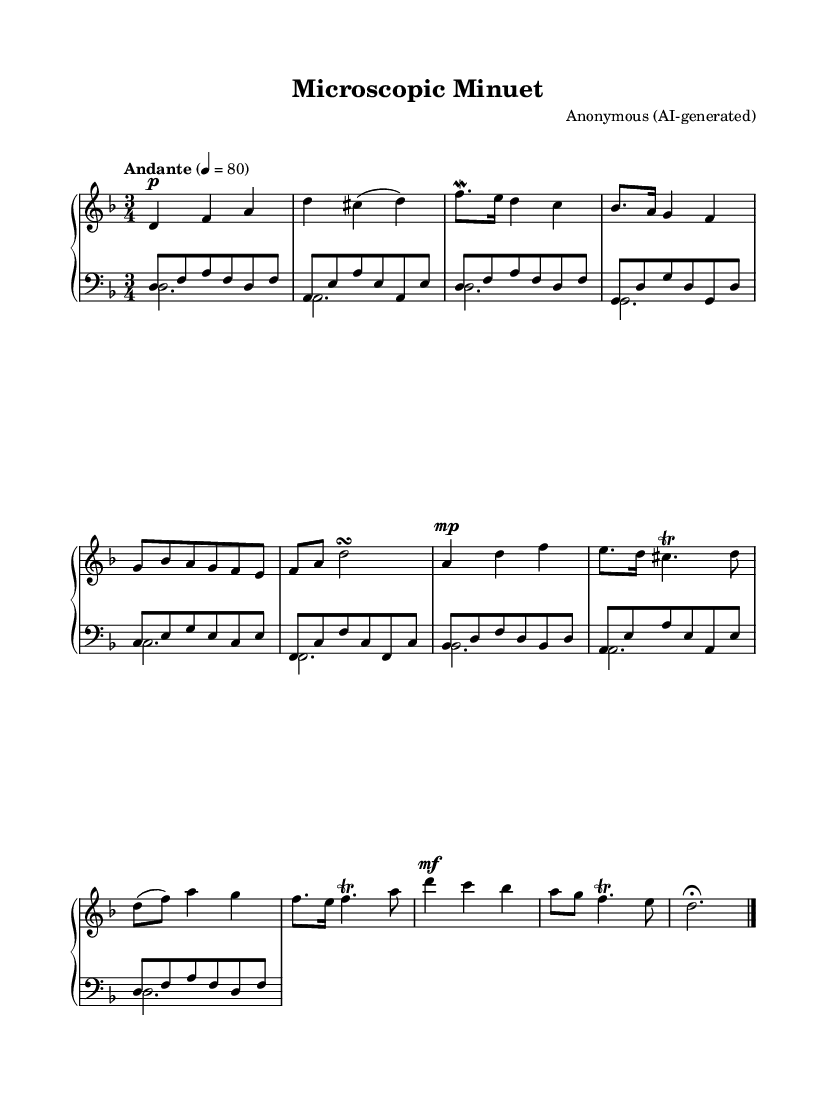What is the key signature of this music? The key signature indicated at the beginning of the sheet music shows two flats, which identifies D minor.
Answer: D minor What is the time signature of this piece? The time signature is displayed as 3/4, indicating that there are three beats per measure.
Answer: 3/4 What is the indicated tempo marking for this composition? The tempo marking written above the staff specifies "Andante" at a speed of 80 beats per minute.
Answer: Andante 4 = 80 How many measures are there in the main theme? By counting the measures in the right-hand part from the beginning, there are six measures that constitute the main theme.
Answer: 6 What type of ornamentation is used in the piece? The music demonstrates the use of mordents and trills, which are characteristic ornaments of the Baroque style, particularly in the right-hand section.
Answer: Mordents and trills In which section does the secondary theme appear? The secondary theme can be identified as starting from the eighth measure onwards, where a different melodic contour is presented.
Answer: Eighth measure 